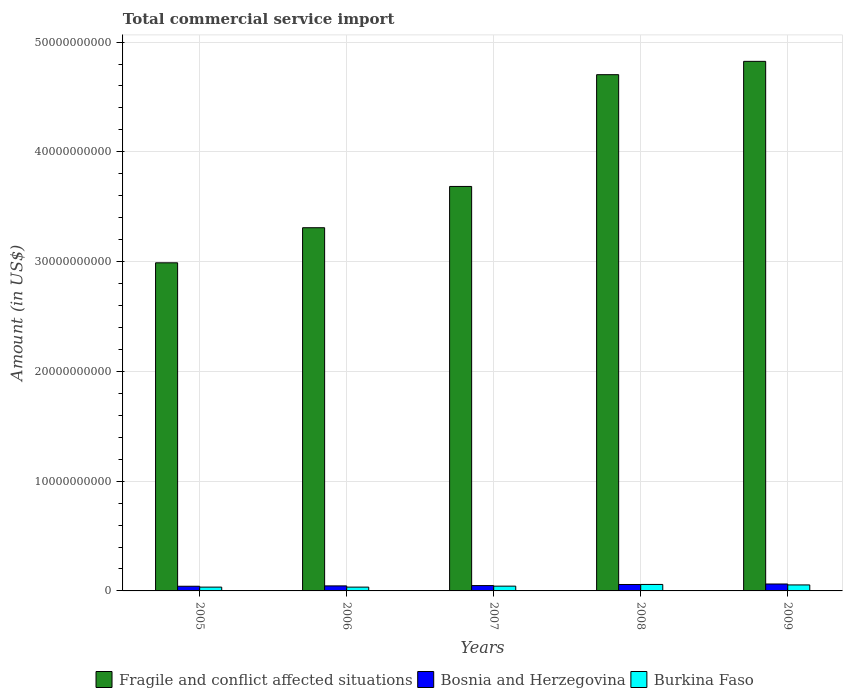How many groups of bars are there?
Offer a very short reply. 5. Are the number of bars per tick equal to the number of legend labels?
Provide a succinct answer. Yes. How many bars are there on the 5th tick from the left?
Keep it short and to the point. 3. What is the label of the 5th group of bars from the left?
Your response must be concise. 2009. What is the total commercial service import in Fragile and conflict affected situations in 2005?
Offer a terse response. 2.99e+1. Across all years, what is the maximum total commercial service import in Fragile and conflict affected situations?
Make the answer very short. 4.82e+1. Across all years, what is the minimum total commercial service import in Burkina Faso?
Your answer should be compact. 3.46e+08. What is the total total commercial service import in Burkina Faso in the graph?
Ensure brevity in your answer.  2.26e+09. What is the difference between the total commercial service import in Burkina Faso in 2008 and that in 2009?
Ensure brevity in your answer.  4.38e+07. What is the difference between the total commercial service import in Burkina Faso in 2008 and the total commercial service import in Bosnia and Herzegovina in 2009?
Provide a succinct answer. -4.09e+07. What is the average total commercial service import in Fragile and conflict affected situations per year?
Offer a terse response. 3.90e+1. In the year 2008, what is the difference between the total commercial service import in Burkina Faso and total commercial service import in Bosnia and Herzegovina?
Offer a very short reply. 5.16e+06. What is the ratio of the total commercial service import in Fragile and conflict affected situations in 2006 to that in 2007?
Your answer should be very brief. 0.9. Is the difference between the total commercial service import in Burkina Faso in 2006 and 2007 greater than the difference between the total commercial service import in Bosnia and Herzegovina in 2006 and 2007?
Your answer should be compact. No. What is the difference between the highest and the second highest total commercial service import in Fragile and conflict affected situations?
Keep it short and to the point. 1.21e+09. What is the difference between the highest and the lowest total commercial service import in Burkina Faso?
Provide a succinct answer. 2.44e+08. What does the 2nd bar from the left in 2005 represents?
Provide a succinct answer. Bosnia and Herzegovina. What does the 1st bar from the right in 2008 represents?
Offer a very short reply. Burkina Faso. How many years are there in the graph?
Ensure brevity in your answer.  5. What is the difference between two consecutive major ticks on the Y-axis?
Provide a short and direct response. 1.00e+1. Are the values on the major ticks of Y-axis written in scientific E-notation?
Offer a terse response. No. Does the graph contain any zero values?
Provide a short and direct response. No. How many legend labels are there?
Ensure brevity in your answer.  3. What is the title of the graph?
Your answer should be very brief. Total commercial service import. What is the label or title of the Y-axis?
Offer a terse response. Amount (in US$). What is the Amount (in US$) in Fragile and conflict affected situations in 2005?
Give a very brief answer. 2.99e+1. What is the Amount (in US$) in Bosnia and Herzegovina in 2005?
Your answer should be compact. 4.25e+08. What is the Amount (in US$) of Burkina Faso in 2005?
Keep it short and to the point. 3.46e+08. What is the Amount (in US$) in Fragile and conflict affected situations in 2006?
Make the answer very short. 3.31e+1. What is the Amount (in US$) of Bosnia and Herzegovina in 2006?
Ensure brevity in your answer.  4.58e+08. What is the Amount (in US$) of Burkina Faso in 2006?
Your response must be concise. 3.46e+08. What is the Amount (in US$) in Fragile and conflict affected situations in 2007?
Provide a short and direct response. 3.68e+1. What is the Amount (in US$) of Bosnia and Herzegovina in 2007?
Keep it short and to the point. 4.87e+08. What is the Amount (in US$) in Burkina Faso in 2007?
Your response must be concise. 4.35e+08. What is the Amount (in US$) of Fragile and conflict affected situations in 2008?
Offer a terse response. 4.70e+1. What is the Amount (in US$) in Bosnia and Herzegovina in 2008?
Keep it short and to the point. 5.85e+08. What is the Amount (in US$) in Burkina Faso in 2008?
Keep it short and to the point. 5.90e+08. What is the Amount (in US$) in Fragile and conflict affected situations in 2009?
Your answer should be compact. 4.82e+1. What is the Amount (in US$) of Bosnia and Herzegovina in 2009?
Give a very brief answer. 6.31e+08. What is the Amount (in US$) of Burkina Faso in 2009?
Your answer should be compact. 5.46e+08. Across all years, what is the maximum Amount (in US$) of Fragile and conflict affected situations?
Provide a succinct answer. 4.82e+1. Across all years, what is the maximum Amount (in US$) of Bosnia and Herzegovina?
Provide a succinct answer. 6.31e+08. Across all years, what is the maximum Amount (in US$) of Burkina Faso?
Provide a short and direct response. 5.90e+08. Across all years, what is the minimum Amount (in US$) of Fragile and conflict affected situations?
Your response must be concise. 2.99e+1. Across all years, what is the minimum Amount (in US$) of Bosnia and Herzegovina?
Make the answer very short. 4.25e+08. Across all years, what is the minimum Amount (in US$) of Burkina Faso?
Provide a short and direct response. 3.46e+08. What is the total Amount (in US$) in Fragile and conflict affected situations in the graph?
Make the answer very short. 1.95e+11. What is the total Amount (in US$) in Bosnia and Herzegovina in the graph?
Make the answer very short. 2.59e+09. What is the total Amount (in US$) of Burkina Faso in the graph?
Keep it short and to the point. 2.26e+09. What is the difference between the Amount (in US$) of Fragile and conflict affected situations in 2005 and that in 2006?
Provide a succinct answer. -3.20e+09. What is the difference between the Amount (in US$) of Bosnia and Herzegovina in 2005 and that in 2006?
Provide a succinct answer. -3.32e+07. What is the difference between the Amount (in US$) of Burkina Faso in 2005 and that in 2006?
Provide a succinct answer. -1.38e+05. What is the difference between the Amount (in US$) of Fragile and conflict affected situations in 2005 and that in 2007?
Ensure brevity in your answer.  -6.96e+09. What is the difference between the Amount (in US$) of Bosnia and Herzegovina in 2005 and that in 2007?
Ensure brevity in your answer.  -6.18e+07. What is the difference between the Amount (in US$) of Burkina Faso in 2005 and that in 2007?
Ensure brevity in your answer.  -8.83e+07. What is the difference between the Amount (in US$) in Fragile and conflict affected situations in 2005 and that in 2008?
Your response must be concise. -1.71e+1. What is the difference between the Amount (in US$) in Bosnia and Herzegovina in 2005 and that in 2008?
Your answer should be very brief. -1.60e+08. What is the difference between the Amount (in US$) of Burkina Faso in 2005 and that in 2008?
Offer a very short reply. -2.44e+08. What is the difference between the Amount (in US$) in Fragile and conflict affected situations in 2005 and that in 2009?
Give a very brief answer. -1.84e+1. What is the difference between the Amount (in US$) in Bosnia and Herzegovina in 2005 and that in 2009?
Keep it short and to the point. -2.06e+08. What is the difference between the Amount (in US$) of Burkina Faso in 2005 and that in 2009?
Your answer should be very brief. -2.00e+08. What is the difference between the Amount (in US$) of Fragile and conflict affected situations in 2006 and that in 2007?
Ensure brevity in your answer.  -3.76e+09. What is the difference between the Amount (in US$) of Bosnia and Herzegovina in 2006 and that in 2007?
Your answer should be very brief. -2.86e+07. What is the difference between the Amount (in US$) of Burkina Faso in 2006 and that in 2007?
Keep it short and to the point. -8.81e+07. What is the difference between the Amount (in US$) in Fragile and conflict affected situations in 2006 and that in 2008?
Provide a succinct answer. -1.39e+1. What is the difference between the Amount (in US$) of Bosnia and Herzegovina in 2006 and that in 2008?
Provide a succinct answer. -1.27e+08. What is the difference between the Amount (in US$) of Burkina Faso in 2006 and that in 2008?
Offer a very short reply. -2.44e+08. What is the difference between the Amount (in US$) of Fragile and conflict affected situations in 2006 and that in 2009?
Your answer should be very brief. -1.52e+1. What is the difference between the Amount (in US$) in Bosnia and Herzegovina in 2006 and that in 2009?
Your answer should be compact. -1.73e+08. What is the difference between the Amount (in US$) of Burkina Faso in 2006 and that in 2009?
Your answer should be compact. -2.00e+08. What is the difference between the Amount (in US$) in Fragile and conflict affected situations in 2007 and that in 2008?
Offer a very short reply. -1.02e+1. What is the difference between the Amount (in US$) in Bosnia and Herzegovina in 2007 and that in 2008?
Ensure brevity in your answer.  -9.84e+07. What is the difference between the Amount (in US$) in Burkina Faso in 2007 and that in 2008?
Your response must be concise. -1.56e+08. What is the difference between the Amount (in US$) in Fragile and conflict affected situations in 2007 and that in 2009?
Offer a terse response. -1.14e+1. What is the difference between the Amount (in US$) of Bosnia and Herzegovina in 2007 and that in 2009?
Your answer should be compact. -1.45e+08. What is the difference between the Amount (in US$) of Burkina Faso in 2007 and that in 2009?
Offer a very short reply. -1.12e+08. What is the difference between the Amount (in US$) in Fragile and conflict affected situations in 2008 and that in 2009?
Offer a very short reply. -1.21e+09. What is the difference between the Amount (in US$) of Bosnia and Herzegovina in 2008 and that in 2009?
Offer a terse response. -4.61e+07. What is the difference between the Amount (in US$) of Burkina Faso in 2008 and that in 2009?
Provide a short and direct response. 4.38e+07. What is the difference between the Amount (in US$) of Fragile and conflict affected situations in 2005 and the Amount (in US$) of Bosnia and Herzegovina in 2006?
Provide a short and direct response. 2.94e+1. What is the difference between the Amount (in US$) in Fragile and conflict affected situations in 2005 and the Amount (in US$) in Burkina Faso in 2006?
Your response must be concise. 2.95e+1. What is the difference between the Amount (in US$) in Bosnia and Herzegovina in 2005 and the Amount (in US$) in Burkina Faso in 2006?
Provide a succinct answer. 7.84e+07. What is the difference between the Amount (in US$) of Fragile and conflict affected situations in 2005 and the Amount (in US$) of Bosnia and Herzegovina in 2007?
Your answer should be very brief. 2.94e+1. What is the difference between the Amount (in US$) of Fragile and conflict affected situations in 2005 and the Amount (in US$) of Burkina Faso in 2007?
Ensure brevity in your answer.  2.95e+1. What is the difference between the Amount (in US$) of Bosnia and Herzegovina in 2005 and the Amount (in US$) of Burkina Faso in 2007?
Keep it short and to the point. -9.68e+06. What is the difference between the Amount (in US$) in Fragile and conflict affected situations in 2005 and the Amount (in US$) in Bosnia and Herzegovina in 2008?
Give a very brief answer. 2.93e+1. What is the difference between the Amount (in US$) in Fragile and conflict affected situations in 2005 and the Amount (in US$) in Burkina Faso in 2008?
Provide a short and direct response. 2.93e+1. What is the difference between the Amount (in US$) in Bosnia and Herzegovina in 2005 and the Amount (in US$) in Burkina Faso in 2008?
Your answer should be compact. -1.65e+08. What is the difference between the Amount (in US$) of Fragile and conflict affected situations in 2005 and the Amount (in US$) of Bosnia and Herzegovina in 2009?
Give a very brief answer. 2.93e+1. What is the difference between the Amount (in US$) in Fragile and conflict affected situations in 2005 and the Amount (in US$) in Burkina Faso in 2009?
Your answer should be compact. 2.93e+1. What is the difference between the Amount (in US$) in Bosnia and Herzegovina in 2005 and the Amount (in US$) in Burkina Faso in 2009?
Make the answer very short. -1.22e+08. What is the difference between the Amount (in US$) in Fragile and conflict affected situations in 2006 and the Amount (in US$) in Bosnia and Herzegovina in 2007?
Provide a succinct answer. 3.26e+1. What is the difference between the Amount (in US$) of Fragile and conflict affected situations in 2006 and the Amount (in US$) of Burkina Faso in 2007?
Your answer should be compact. 3.27e+1. What is the difference between the Amount (in US$) in Bosnia and Herzegovina in 2006 and the Amount (in US$) in Burkina Faso in 2007?
Provide a short and direct response. 2.35e+07. What is the difference between the Amount (in US$) in Fragile and conflict affected situations in 2006 and the Amount (in US$) in Bosnia and Herzegovina in 2008?
Provide a succinct answer. 3.25e+1. What is the difference between the Amount (in US$) in Fragile and conflict affected situations in 2006 and the Amount (in US$) in Burkina Faso in 2008?
Provide a short and direct response. 3.25e+1. What is the difference between the Amount (in US$) in Bosnia and Herzegovina in 2006 and the Amount (in US$) in Burkina Faso in 2008?
Your answer should be very brief. -1.32e+08. What is the difference between the Amount (in US$) of Fragile and conflict affected situations in 2006 and the Amount (in US$) of Bosnia and Herzegovina in 2009?
Make the answer very short. 3.25e+1. What is the difference between the Amount (in US$) of Fragile and conflict affected situations in 2006 and the Amount (in US$) of Burkina Faso in 2009?
Provide a short and direct response. 3.25e+1. What is the difference between the Amount (in US$) in Bosnia and Herzegovina in 2006 and the Amount (in US$) in Burkina Faso in 2009?
Keep it short and to the point. -8.84e+07. What is the difference between the Amount (in US$) of Fragile and conflict affected situations in 2007 and the Amount (in US$) of Bosnia and Herzegovina in 2008?
Make the answer very short. 3.63e+1. What is the difference between the Amount (in US$) in Fragile and conflict affected situations in 2007 and the Amount (in US$) in Burkina Faso in 2008?
Provide a succinct answer. 3.63e+1. What is the difference between the Amount (in US$) in Bosnia and Herzegovina in 2007 and the Amount (in US$) in Burkina Faso in 2008?
Offer a very short reply. -1.04e+08. What is the difference between the Amount (in US$) of Fragile and conflict affected situations in 2007 and the Amount (in US$) of Bosnia and Herzegovina in 2009?
Keep it short and to the point. 3.62e+1. What is the difference between the Amount (in US$) in Fragile and conflict affected situations in 2007 and the Amount (in US$) in Burkina Faso in 2009?
Ensure brevity in your answer.  3.63e+1. What is the difference between the Amount (in US$) in Bosnia and Herzegovina in 2007 and the Amount (in US$) in Burkina Faso in 2009?
Make the answer very short. -5.98e+07. What is the difference between the Amount (in US$) of Fragile and conflict affected situations in 2008 and the Amount (in US$) of Bosnia and Herzegovina in 2009?
Give a very brief answer. 4.64e+1. What is the difference between the Amount (in US$) in Fragile and conflict affected situations in 2008 and the Amount (in US$) in Burkina Faso in 2009?
Your response must be concise. 4.65e+1. What is the difference between the Amount (in US$) in Bosnia and Herzegovina in 2008 and the Amount (in US$) in Burkina Faso in 2009?
Make the answer very short. 3.87e+07. What is the average Amount (in US$) of Fragile and conflict affected situations per year?
Offer a very short reply. 3.90e+1. What is the average Amount (in US$) in Bosnia and Herzegovina per year?
Your answer should be compact. 5.17e+08. What is the average Amount (in US$) of Burkina Faso per year?
Your answer should be compact. 4.53e+08. In the year 2005, what is the difference between the Amount (in US$) in Fragile and conflict affected situations and Amount (in US$) in Bosnia and Herzegovina?
Ensure brevity in your answer.  2.95e+1. In the year 2005, what is the difference between the Amount (in US$) in Fragile and conflict affected situations and Amount (in US$) in Burkina Faso?
Your answer should be very brief. 2.95e+1. In the year 2005, what is the difference between the Amount (in US$) of Bosnia and Herzegovina and Amount (in US$) of Burkina Faso?
Ensure brevity in your answer.  7.86e+07. In the year 2006, what is the difference between the Amount (in US$) in Fragile and conflict affected situations and Amount (in US$) in Bosnia and Herzegovina?
Your response must be concise. 3.26e+1. In the year 2006, what is the difference between the Amount (in US$) of Fragile and conflict affected situations and Amount (in US$) of Burkina Faso?
Provide a succinct answer. 3.27e+1. In the year 2006, what is the difference between the Amount (in US$) of Bosnia and Herzegovina and Amount (in US$) of Burkina Faso?
Your response must be concise. 1.12e+08. In the year 2007, what is the difference between the Amount (in US$) in Fragile and conflict affected situations and Amount (in US$) in Bosnia and Herzegovina?
Offer a very short reply. 3.64e+1. In the year 2007, what is the difference between the Amount (in US$) of Fragile and conflict affected situations and Amount (in US$) of Burkina Faso?
Offer a very short reply. 3.64e+1. In the year 2007, what is the difference between the Amount (in US$) in Bosnia and Herzegovina and Amount (in US$) in Burkina Faso?
Your answer should be very brief. 5.21e+07. In the year 2008, what is the difference between the Amount (in US$) of Fragile and conflict affected situations and Amount (in US$) of Bosnia and Herzegovina?
Provide a short and direct response. 4.64e+1. In the year 2008, what is the difference between the Amount (in US$) in Fragile and conflict affected situations and Amount (in US$) in Burkina Faso?
Offer a very short reply. 4.64e+1. In the year 2008, what is the difference between the Amount (in US$) of Bosnia and Herzegovina and Amount (in US$) of Burkina Faso?
Provide a short and direct response. -5.16e+06. In the year 2009, what is the difference between the Amount (in US$) in Fragile and conflict affected situations and Amount (in US$) in Bosnia and Herzegovina?
Your answer should be compact. 4.76e+1. In the year 2009, what is the difference between the Amount (in US$) of Fragile and conflict affected situations and Amount (in US$) of Burkina Faso?
Give a very brief answer. 4.77e+1. In the year 2009, what is the difference between the Amount (in US$) of Bosnia and Herzegovina and Amount (in US$) of Burkina Faso?
Make the answer very short. 8.47e+07. What is the ratio of the Amount (in US$) of Fragile and conflict affected situations in 2005 to that in 2006?
Your answer should be compact. 0.9. What is the ratio of the Amount (in US$) of Bosnia and Herzegovina in 2005 to that in 2006?
Your answer should be compact. 0.93. What is the ratio of the Amount (in US$) of Fragile and conflict affected situations in 2005 to that in 2007?
Keep it short and to the point. 0.81. What is the ratio of the Amount (in US$) in Bosnia and Herzegovina in 2005 to that in 2007?
Your answer should be very brief. 0.87. What is the ratio of the Amount (in US$) of Burkina Faso in 2005 to that in 2007?
Make the answer very short. 0.8. What is the ratio of the Amount (in US$) of Fragile and conflict affected situations in 2005 to that in 2008?
Give a very brief answer. 0.64. What is the ratio of the Amount (in US$) of Bosnia and Herzegovina in 2005 to that in 2008?
Provide a succinct answer. 0.73. What is the ratio of the Amount (in US$) of Burkina Faso in 2005 to that in 2008?
Provide a succinct answer. 0.59. What is the ratio of the Amount (in US$) of Fragile and conflict affected situations in 2005 to that in 2009?
Offer a terse response. 0.62. What is the ratio of the Amount (in US$) of Bosnia and Herzegovina in 2005 to that in 2009?
Provide a succinct answer. 0.67. What is the ratio of the Amount (in US$) of Burkina Faso in 2005 to that in 2009?
Your response must be concise. 0.63. What is the ratio of the Amount (in US$) of Fragile and conflict affected situations in 2006 to that in 2007?
Offer a very short reply. 0.9. What is the ratio of the Amount (in US$) in Bosnia and Herzegovina in 2006 to that in 2007?
Give a very brief answer. 0.94. What is the ratio of the Amount (in US$) of Burkina Faso in 2006 to that in 2007?
Provide a succinct answer. 0.8. What is the ratio of the Amount (in US$) of Fragile and conflict affected situations in 2006 to that in 2008?
Offer a terse response. 0.7. What is the ratio of the Amount (in US$) in Bosnia and Herzegovina in 2006 to that in 2008?
Your answer should be compact. 0.78. What is the ratio of the Amount (in US$) of Burkina Faso in 2006 to that in 2008?
Ensure brevity in your answer.  0.59. What is the ratio of the Amount (in US$) in Fragile and conflict affected situations in 2006 to that in 2009?
Your response must be concise. 0.69. What is the ratio of the Amount (in US$) of Bosnia and Herzegovina in 2006 to that in 2009?
Your response must be concise. 0.73. What is the ratio of the Amount (in US$) in Burkina Faso in 2006 to that in 2009?
Your answer should be very brief. 0.63. What is the ratio of the Amount (in US$) in Fragile and conflict affected situations in 2007 to that in 2008?
Keep it short and to the point. 0.78. What is the ratio of the Amount (in US$) in Bosnia and Herzegovina in 2007 to that in 2008?
Give a very brief answer. 0.83. What is the ratio of the Amount (in US$) in Burkina Faso in 2007 to that in 2008?
Make the answer very short. 0.74. What is the ratio of the Amount (in US$) of Fragile and conflict affected situations in 2007 to that in 2009?
Ensure brevity in your answer.  0.76. What is the ratio of the Amount (in US$) in Bosnia and Herzegovina in 2007 to that in 2009?
Offer a very short reply. 0.77. What is the ratio of the Amount (in US$) of Burkina Faso in 2007 to that in 2009?
Offer a very short reply. 0.8. What is the ratio of the Amount (in US$) of Fragile and conflict affected situations in 2008 to that in 2009?
Offer a terse response. 0.97. What is the ratio of the Amount (in US$) of Bosnia and Herzegovina in 2008 to that in 2009?
Give a very brief answer. 0.93. What is the ratio of the Amount (in US$) of Burkina Faso in 2008 to that in 2009?
Your answer should be compact. 1.08. What is the difference between the highest and the second highest Amount (in US$) in Fragile and conflict affected situations?
Keep it short and to the point. 1.21e+09. What is the difference between the highest and the second highest Amount (in US$) in Bosnia and Herzegovina?
Make the answer very short. 4.61e+07. What is the difference between the highest and the second highest Amount (in US$) in Burkina Faso?
Ensure brevity in your answer.  4.38e+07. What is the difference between the highest and the lowest Amount (in US$) of Fragile and conflict affected situations?
Make the answer very short. 1.84e+1. What is the difference between the highest and the lowest Amount (in US$) of Bosnia and Herzegovina?
Provide a succinct answer. 2.06e+08. What is the difference between the highest and the lowest Amount (in US$) of Burkina Faso?
Provide a succinct answer. 2.44e+08. 